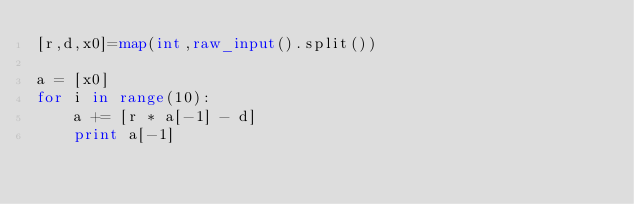Convert code to text. <code><loc_0><loc_0><loc_500><loc_500><_Python_>[r,d,x0]=map(int,raw_input().split())

a = [x0]
for i in range(10):
	a += [r * a[-1] - d]
	print a[-1]
</code> 